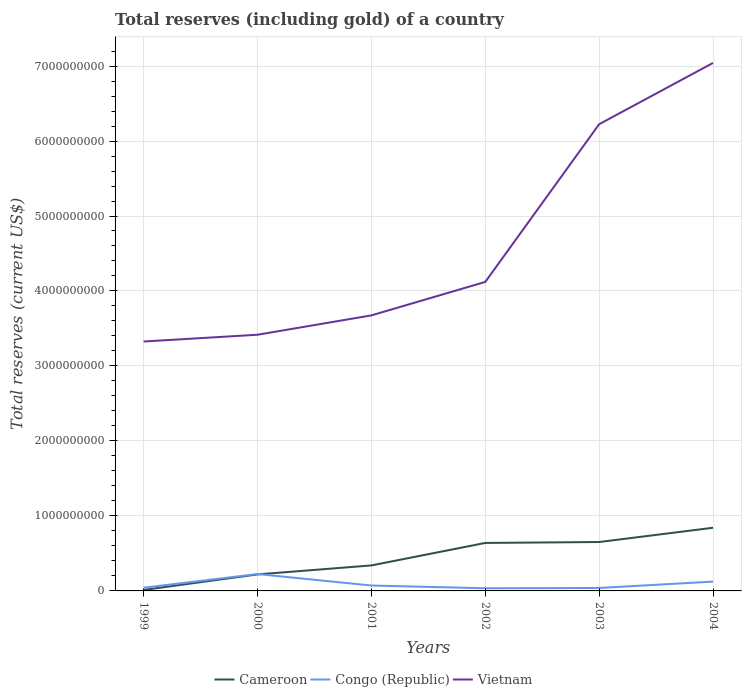Across all years, what is the maximum total reserves (including gold) in Congo (Republic)?
Your answer should be very brief. 3.54e+07. In which year was the total reserves (including gold) in Vietnam maximum?
Make the answer very short. 1999. What is the total total reserves (including gold) in Congo (Republic) in the graph?
Your response must be concise. 3.65e+07. What is the difference between the highest and the second highest total reserves (including gold) in Congo (Republic)?
Offer a terse response. 1.90e+08. What is the difference between the highest and the lowest total reserves (including gold) in Cameroon?
Offer a terse response. 3. Is the total reserves (including gold) in Vietnam strictly greater than the total reserves (including gold) in Cameroon over the years?
Offer a very short reply. No. How many years are there in the graph?
Your answer should be very brief. 6. Does the graph contain any zero values?
Offer a terse response. No. Does the graph contain grids?
Provide a short and direct response. Yes. Where does the legend appear in the graph?
Give a very brief answer. Bottom center. How many legend labels are there?
Make the answer very short. 3. What is the title of the graph?
Ensure brevity in your answer.  Total reserves (including gold) of a country. What is the label or title of the Y-axis?
Your answer should be compact. Total reserves (current US$). What is the Total reserves (current US$) in Cameroon in 1999?
Give a very brief answer. 1.31e+07. What is the Total reserves (current US$) of Congo (Republic) in 1999?
Your response must be concise. 4.26e+07. What is the Total reserves (current US$) in Vietnam in 1999?
Ensure brevity in your answer.  3.33e+09. What is the Total reserves (current US$) of Cameroon in 2000?
Give a very brief answer. 2.20e+08. What is the Total reserves (current US$) in Congo (Republic) in 2000?
Your answer should be compact. 2.25e+08. What is the Total reserves (current US$) in Vietnam in 2000?
Provide a succinct answer. 3.42e+09. What is the Total reserves (current US$) in Cameroon in 2001?
Your answer should be very brief. 3.40e+08. What is the Total reserves (current US$) in Congo (Republic) in 2001?
Offer a terse response. 7.20e+07. What is the Total reserves (current US$) in Vietnam in 2001?
Offer a very short reply. 3.67e+09. What is the Total reserves (current US$) in Cameroon in 2002?
Keep it short and to the point. 6.40e+08. What is the Total reserves (current US$) in Congo (Republic) in 2002?
Offer a terse response. 3.54e+07. What is the Total reserves (current US$) of Vietnam in 2002?
Ensure brevity in your answer.  4.12e+09. What is the Total reserves (current US$) of Cameroon in 2003?
Offer a terse response. 6.52e+08. What is the Total reserves (current US$) of Congo (Republic) in 2003?
Provide a succinct answer. 3.94e+07. What is the Total reserves (current US$) of Vietnam in 2003?
Your answer should be very brief. 6.22e+09. What is the Total reserves (current US$) in Cameroon in 2004?
Provide a succinct answer. 8.42e+08. What is the Total reserves (current US$) in Congo (Republic) in 2004?
Provide a succinct answer. 1.24e+08. What is the Total reserves (current US$) in Vietnam in 2004?
Ensure brevity in your answer.  7.04e+09. Across all years, what is the maximum Total reserves (current US$) in Cameroon?
Provide a short and direct response. 8.42e+08. Across all years, what is the maximum Total reserves (current US$) of Congo (Republic)?
Provide a short and direct response. 2.25e+08. Across all years, what is the maximum Total reserves (current US$) in Vietnam?
Make the answer very short. 7.04e+09. Across all years, what is the minimum Total reserves (current US$) of Cameroon?
Your answer should be very brief. 1.31e+07. Across all years, what is the minimum Total reserves (current US$) of Congo (Republic)?
Ensure brevity in your answer.  3.54e+07. Across all years, what is the minimum Total reserves (current US$) of Vietnam?
Keep it short and to the point. 3.33e+09. What is the total Total reserves (current US$) in Cameroon in the graph?
Offer a terse response. 2.71e+09. What is the total Total reserves (current US$) in Congo (Republic) in the graph?
Your answer should be compact. 5.39e+08. What is the total Total reserves (current US$) of Vietnam in the graph?
Your answer should be very brief. 2.78e+1. What is the difference between the Total reserves (current US$) of Cameroon in 1999 and that in 2000?
Provide a short and direct response. -2.07e+08. What is the difference between the Total reserves (current US$) in Congo (Republic) in 1999 and that in 2000?
Your answer should be very brief. -1.82e+08. What is the difference between the Total reserves (current US$) of Vietnam in 1999 and that in 2000?
Your response must be concise. -9.04e+07. What is the difference between the Total reserves (current US$) of Cameroon in 1999 and that in 2001?
Your response must be concise. -3.27e+08. What is the difference between the Total reserves (current US$) of Congo (Republic) in 1999 and that in 2001?
Offer a very short reply. -2.94e+07. What is the difference between the Total reserves (current US$) in Vietnam in 1999 and that in 2001?
Provide a succinct answer. -3.48e+08. What is the difference between the Total reserves (current US$) of Cameroon in 1999 and that in 2002?
Give a very brief answer. -6.27e+08. What is the difference between the Total reserves (current US$) in Congo (Republic) in 1999 and that in 2002?
Offer a very short reply. 7.14e+06. What is the difference between the Total reserves (current US$) of Vietnam in 1999 and that in 2002?
Make the answer very short. -7.95e+08. What is the difference between the Total reserves (current US$) in Cameroon in 1999 and that in 2003?
Offer a terse response. -6.39e+08. What is the difference between the Total reserves (current US$) of Congo (Republic) in 1999 and that in 2003?
Offer a very short reply. 3.14e+06. What is the difference between the Total reserves (current US$) in Vietnam in 1999 and that in 2003?
Your response must be concise. -2.90e+09. What is the difference between the Total reserves (current US$) in Cameroon in 1999 and that in 2004?
Give a very brief answer. -8.29e+08. What is the difference between the Total reserves (current US$) in Congo (Republic) in 1999 and that in 2004?
Keep it short and to the point. -8.19e+07. What is the difference between the Total reserves (current US$) in Vietnam in 1999 and that in 2004?
Provide a succinct answer. -3.72e+09. What is the difference between the Total reserves (current US$) of Cameroon in 2000 and that in 2001?
Your answer should be compact. -1.20e+08. What is the difference between the Total reserves (current US$) of Congo (Republic) in 2000 and that in 2001?
Provide a short and direct response. 1.53e+08. What is the difference between the Total reserves (current US$) in Vietnam in 2000 and that in 2001?
Your response must be concise. -2.58e+08. What is the difference between the Total reserves (current US$) in Cameroon in 2000 and that in 2002?
Your response must be concise. -4.20e+08. What is the difference between the Total reserves (current US$) in Congo (Republic) in 2000 and that in 2002?
Keep it short and to the point. 1.90e+08. What is the difference between the Total reserves (current US$) in Vietnam in 2000 and that in 2002?
Offer a terse response. -7.05e+08. What is the difference between the Total reserves (current US$) in Cameroon in 2000 and that in 2003?
Give a very brief answer. -4.32e+08. What is the difference between the Total reserves (current US$) of Congo (Republic) in 2000 and that in 2003?
Provide a succinct answer. 1.86e+08. What is the difference between the Total reserves (current US$) in Vietnam in 2000 and that in 2003?
Your response must be concise. -2.81e+09. What is the difference between the Total reserves (current US$) in Cameroon in 2000 and that in 2004?
Ensure brevity in your answer.  -6.22e+08. What is the difference between the Total reserves (current US$) of Congo (Republic) in 2000 and that in 2004?
Provide a short and direct response. 1.01e+08. What is the difference between the Total reserves (current US$) in Vietnam in 2000 and that in 2004?
Offer a very short reply. -3.62e+09. What is the difference between the Total reserves (current US$) of Cameroon in 2001 and that in 2002?
Offer a terse response. -3.00e+08. What is the difference between the Total reserves (current US$) of Congo (Republic) in 2001 and that in 2002?
Make the answer very short. 3.65e+07. What is the difference between the Total reserves (current US$) in Vietnam in 2001 and that in 2002?
Your answer should be compact. -4.46e+08. What is the difference between the Total reserves (current US$) in Cameroon in 2001 and that in 2003?
Provide a succinct answer. -3.12e+08. What is the difference between the Total reserves (current US$) of Congo (Republic) in 2001 and that in 2003?
Provide a short and direct response. 3.25e+07. What is the difference between the Total reserves (current US$) in Vietnam in 2001 and that in 2003?
Your answer should be compact. -2.55e+09. What is the difference between the Total reserves (current US$) of Cameroon in 2001 and that in 2004?
Your answer should be compact. -5.02e+08. What is the difference between the Total reserves (current US$) of Congo (Republic) in 2001 and that in 2004?
Your answer should be compact. -5.25e+07. What is the difference between the Total reserves (current US$) of Vietnam in 2001 and that in 2004?
Offer a terse response. -3.37e+09. What is the difference between the Total reserves (current US$) in Cameroon in 2002 and that in 2003?
Your answer should be compact. -1.22e+07. What is the difference between the Total reserves (current US$) of Congo (Republic) in 2002 and that in 2003?
Ensure brevity in your answer.  -3.99e+06. What is the difference between the Total reserves (current US$) of Vietnam in 2002 and that in 2003?
Ensure brevity in your answer.  -2.10e+09. What is the difference between the Total reserves (current US$) in Cameroon in 2002 and that in 2004?
Ensure brevity in your answer.  -2.02e+08. What is the difference between the Total reserves (current US$) of Congo (Republic) in 2002 and that in 2004?
Your answer should be very brief. -8.90e+07. What is the difference between the Total reserves (current US$) of Vietnam in 2002 and that in 2004?
Your response must be concise. -2.92e+09. What is the difference between the Total reserves (current US$) in Cameroon in 2003 and that in 2004?
Keep it short and to the point. -1.90e+08. What is the difference between the Total reserves (current US$) in Congo (Republic) in 2003 and that in 2004?
Your answer should be very brief. -8.50e+07. What is the difference between the Total reserves (current US$) in Vietnam in 2003 and that in 2004?
Provide a succinct answer. -8.17e+08. What is the difference between the Total reserves (current US$) of Cameroon in 1999 and the Total reserves (current US$) of Congo (Republic) in 2000?
Ensure brevity in your answer.  -2.12e+08. What is the difference between the Total reserves (current US$) in Cameroon in 1999 and the Total reserves (current US$) in Vietnam in 2000?
Offer a terse response. -3.40e+09. What is the difference between the Total reserves (current US$) in Congo (Republic) in 1999 and the Total reserves (current US$) in Vietnam in 2000?
Offer a very short reply. -3.37e+09. What is the difference between the Total reserves (current US$) of Cameroon in 1999 and the Total reserves (current US$) of Congo (Republic) in 2001?
Offer a terse response. -5.89e+07. What is the difference between the Total reserves (current US$) in Cameroon in 1999 and the Total reserves (current US$) in Vietnam in 2001?
Your response must be concise. -3.66e+09. What is the difference between the Total reserves (current US$) in Congo (Republic) in 1999 and the Total reserves (current US$) in Vietnam in 2001?
Your response must be concise. -3.63e+09. What is the difference between the Total reserves (current US$) in Cameroon in 1999 and the Total reserves (current US$) in Congo (Republic) in 2002?
Ensure brevity in your answer.  -2.23e+07. What is the difference between the Total reserves (current US$) in Cameroon in 1999 and the Total reserves (current US$) in Vietnam in 2002?
Keep it short and to the point. -4.11e+09. What is the difference between the Total reserves (current US$) of Congo (Republic) in 1999 and the Total reserves (current US$) of Vietnam in 2002?
Your answer should be compact. -4.08e+09. What is the difference between the Total reserves (current US$) of Cameroon in 1999 and the Total reserves (current US$) of Congo (Republic) in 2003?
Your answer should be very brief. -2.63e+07. What is the difference between the Total reserves (current US$) in Cameroon in 1999 and the Total reserves (current US$) in Vietnam in 2003?
Offer a terse response. -6.21e+09. What is the difference between the Total reserves (current US$) in Congo (Republic) in 1999 and the Total reserves (current US$) in Vietnam in 2003?
Provide a short and direct response. -6.18e+09. What is the difference between the Total reserves (current US$) in Cameroon in 1999 and the Total reserves (current US$) in Congo (Republic) in 2004?
Your answer should be compact. -1.11e+08. What is the difference between the Total reserves (current US$) in Cameroon in 1999 and the Total reserves (current US$) in Vietnam in 2004?
Keep it short and to the point. -7.03e+09. What is the difference between the Total reserves (current US$) in Congo (Republic) in 1999 and the Total reserves (current US$) in Vietnam in 2004?
Offer a very short reply. -7.00e+09. What is the difference between the Total reserves (current US$) in Cameroon in 2000 and the Total reserves (current US$) in Congo (Republic) in 2001?
Your answer should be compact. 1.48e+08. What is the difference between the Total reserves (current US$) of Cameroon in 2000 and the Total reserves (current US$) of Vietnam in 2001?
Your answer should be compact. -3.45e+09. What is the difference between the Total reserves (current US$) in Congo (Republic) in 2000 and the Total reserves (current US$) in Vietnam in 2001?
Keep it short and to the point. -3.45e+09. What is the difference between the Total reserves (current US$) in Cameroon in 2000 and the Total reserves (current US$) in Congo (Republic) in 2002?
Your answer should be compact. 1.85e+08. What is the difference between the Total reserves (current US$) of Cameroon in 2000 and the Total reserves (current US$) of Vietnam in 2002?
Your answer should be very brief. -3.90e+09. What is the difference between the Total reserves (current US$) of Congo (Republic) in 2000 and the Total reserves (current US$) of Vietnam in 2002?
Give a very brief answer. -3.90e+09. What is the difference between the Total reserves (current US$) in Cameroon in 2000 and the Total reserves (current US$) in Congo (Republic) in 2003?
Keep it short and to the point. 1.81e+08. What is the difference between the Total reserves (current US$) of Cameroon in 2000 and the Total reserves (current US$) of Vietnam in 2003?
Offer a very short reply. -6.00e+09. What is the difference between the Total reserves (current US$) in Congo (Republic) in 2000 and the Total reserves (current US$) in Vietnam in 2003?
Your answer should be compact. -6.00e+09. What is the difference between the Total reserves (current US$) of Cameroon in 2000 and the Total reserves (current US$) of Congo (Republic) in 2004?
Your response must be concise. 9.57e+07. What is the difference between the Total reserves (current US$) in Cameroon in 2000 and the Total reserves (current US$) in Vietnam in 2004?
Your answer should be compact. -6.82e+09. What is the difference between the Total reserves (current US$) of Congo (Republic) in 2000 and the Total reserves (current US$) of Vietnam in 2004?
Offer a very short reply. -6.82e+09. What is the difference between the Total reserves (current US$) of Cameroon in 2001 and the Total reserves (current US$) of Congo (Republic) in 2002?
Ensure brevity in your answer.  3.05e+08. What is the difference between the Total reserves (current US$) of Cameroon in 2001 and the Total reserves (current US$) of Vietnam in 2002?
Your response must be concise. -3.78e+09. What is the difference between the Total reserves (current US$) of Congo (Republic) in 2001 and the Total reserves (current US$) of Vietnam in 2002?
Your response must be concise. -4.05e+09. What is the difference between the Total reserves (current US$) in Cameroon in 2001 and the Total reserves (current US$) in Congo (Republic) in 2003?
Your answer should be very brief. 3.01e+08. What is the difference between the Total reserves (current US$) of Cameroon in 2001 and the Total reserves (current US$) of Vietnam in 2003?
Offer a very short reply. -5.88e+09. What is the difference between the Total reserves (current US$) of Congo (Republic) in 2001 and the Total reserves (current US$) of Vietnam in 2003?
Offer a terse response. -6.15e+09. What is the difference between the Total reserves (current US$) in Cameroon in 2001 and the Total reserves (current US$) in Congo (Republic) in 2004?
Your answer should be very brief. 2.16e+08. What is the difference between the Total reserves (current US$) in Cameroon in 2001 and the Total reserves (current US$) in Vietnam in 2004?
Ensure brevity in your answer.  -6.70e+09. What is the difference between the Total reserves (current US$) in Congo (Republic) in 2001 and the Total reserves (current US$) in Vietnam in 2004?
Offer a terse response. -6.97e+09. What is the difference between the Total reserves (current US$) in Cameroon in 2002 and the Total reserves (current US$) in Congo (Republic) in 2003?
Give a very brief answer. 6.00e+08. What is the difference between the Total reserves (current US$) in Cameroon in 2002 and the Total reserves (current US$) in Vietnam in 2003?
Your response must be concise. -5.58e+09. What is the difference between the Total reserves (current US$) in Congo (Republic) in 2002 and the Total reserves (current US$) in Vietnam in 2003?
Offer a very short reply. -6.19e+09. What is the difference between the Total reserves (current US$) in Cameroon in 2002 and the Total reserves (current US$) in Congo (Republic) in 2004?
Offer a terse response. 5.15e+08. What is the difference between the Total reserves (current US$) in Cameroon in 2002 and the Total reserves (current US$) in Vietnam in 2004?
Your answer should be compact. -6.40e+09. What is the difference between the Total reserves (current US$) of Congo (Republic) in 2002 and the Total reserves (current US$) of Vietnam in 2004?
Keep it short and to the point. -7.01e+09. What is the difference between the Total reserves (current US$) in Cameroon in 2003 and the Total reserves (current US$) in Congo (Republic) in 2004?
Make the answer very short. 5.28e+08. What is the difference between the Total reserves (current US$) of Cameroon in 2003 and the Total reserves (current US$) of Vietnam in 2004?
Your answer should be very brief. -6.39e+09. What is the difference between the Total reserves (current US$) in Congo (Republic) in 2003 and the Total reserves (current US$) in Vietnam in 2004?
Provide a succinct answer. -7.00e+09. What is the average Total reserves (current US$) in Cameroon per year?
Offer a very short reply. 4.51e+08. What is the average Total reserves (current US$) of Congo (Republic) per year?
Your answer should be very brief. 8.98e+07. What is the average Total reserves (current US$) of Vietnam per year?
Keep it short and to the point. 4.63e+09. In the year 1999, what is the difference between the Total reserves (current US$) in Cameroon and Total reserves (current US$) in Congo (Republic)?
Your answer should be compact. -2.95e+07. In the year 1999, what is the difference between the Total reserves (current US$) of Cameroon and Total reserves (current US$) of Vietnam?
Your response must be concise. -3.31e+09. In the year 1999, what is the difference between the Total reserves (current US$) in Congo (Republic) and Total reserves (current US$) in Vietnam?
Make the answer very short. -3.28e+09. In the year 2000, what is the difference between the Total reserves (current US$) of Cameroon and Total reserves (current US$) of Congo (Republic)?
Provide a succinct answer. -4.84e+06. In the year 2000, what is the difference between the Total reserves (current US$) in Cameroon and Total reserves (current US$) in Vietnam?
Offer a very short reply. -3.20e+09. In the year 2000, what is the difference between the Total reserves (current US$) in Congo (Republic) and Total reserves (current US$) in Vietnam?
Provide a succinct answer. -3.19e+09. In the year 2001, what is the difference between the Total reserves (current US$) of Cameroon and Total reserves (current US$) of Congo (Republic)?
Your answer should be very brief. 2.68e+08. In the year 2001, what is the difference between the Total reserves (current US$) in Cameroon and Total reserves (current US$) in Vietnam?
Provide a succinct answer. -3.33e+09. In the year 2001, what is the difference between the Total reserves (current US$) in Congo (Republic) and Total reserves (current US$) in Vietnam?
Your answer should be very brief. -3.60e+09. In the year 2002, what is the difference between the Total reserves (current US$) in Cameroon and Total reserves (current US$) in Congo (Republic)?
Make the answer very short. 6.04e+08. In the year 2002, what is the difference between the Total reserves (current US$) in Cameroon and Total reserves (current US$) in Vietnam?
Keep it short and to the point. -3.48e+09. In the year 2002, what is the difference between the Total reserves (current US$) of Congo (Republic) and Total reserves (current US$) of Vietnam?
Offer a terse response. -4.09e+09. In the year 2003, what is the difference between the Total reserves (current US$) of Cameroon and Total reserves (current US$) of Congo (Republic)?
Your answer should be compact. 6.13e+08. In the year 2003, what is the difference between the Total reserves (current US$) in Cameroon and Total reserves (current US$) in Vietnam?
Offer a very short reply. -5.57e+09. In the year 2003, what is the difference between the Total reserves (current US$) of Congo (Republic) and Total reserves (current US$) of Vietnam?
Make the answer very short. -6.18e+09. In the year 2004, what is the difference between the Total reserves (current US$) in Cameroon and Total reserves (current US$) in Congo (Republic)?
Ensure brevity in your answer.  7.18e+08. In the year 2004, what is the difference between the Total reserves (current US$) in Cameroon and Total reserves (current US$) in Vietnam?
Provide a short and direct response. -6.20e+09. In the year 2004, what is the difference between the Total reserves (current US$) of Congo (Republic) and Total reserves (current US$) of Vietnam?
Your answer should be compact. -6.92e+09. What is the ratio of the Total reserves (current US$) in Cameroon in 1999 to that in 2000?
Give a very brief answer. 0.06. What is the ratio of the Total reserves (current US$) in Congo (Republic) in 1999 to that in 2000?
Offer a terse response. 0.19. What is the ratio of the Total reserves (current US$) of Vietnam in 1999 to that in 2000?
Give a very brief answer. 0.97. What is the ratio of the Total reserves (current US$) of Cameroon in 1999 to that in 2001?
Offer a very short reply. 0.04. What is the ratio of the Total reserves (current US$) in Congo (Republic) in 1999 to that in 2001?
Your answer should be compact. 0.59. What is the ratio of the Total reserves (current US$) in Vietnam in 1999 to that in 2001?
Your response must be concise. 0.91. What is the ratio of the Total reserves (current US$) of Cameroon in 1999 to that in 2002?
Provide a short and direct response. 0.02. What is the ratio of the Total reserves (current US$) of Congo (Republic) in 1999 to that in 2002?
Give a very brief answer. 1.2. What is the ratio of the Total reserves (current US$) in Vietnam in 1999 to that in 2002?
Your response must be concise. 0.81. What is the ratio of the Total reserves (current US$) in Cameroon in 1999 to that in 2003?
Give a very brief answer. 0.02. What is the ratio of the Total reserves (current US$) in Congo (Republic) in 1999 to that in 2003?
Provide a short and direct response. 1.08. What is the ratio of the Total reserves (current US$) of Vietnam in 1999 to that in 2003?
Give a very brief answer. 0.53. What is the ratio of the Total reserves (current US$) of Cameroon in 1999 to that in 2004?
Your answer should be very brief. 0.02. What is the ratio of the Total reserves (current US$) in Congo (Republic) in 1999 to that in 2004?
Make the answer very short. 0.34. What is the ratio of the Total reserves (current US$) of Vietnam in 1999 to that in 2004?
Provide a short and direct response. 0.47. What is the ratio of the Total reserves (current US$) in Cameroon in 2000 to that in 2001?
Offer a terse response. 0.65. What is the ratio of the Total reserves (current US$) in Congo (Republic) in 2000 to that in 2001?
Provide a short and direct response. 3.13. What is the ratio of the Total reserves (current US$) in Vietnam in 2000 to that in 2001?
Your response must be concise. 0.93. What is the ratio of the Total reserves (current US$) of Cameroon in 2000 to that in 2002?
Provide a short and direct response. 0.34. What is the ratio of the Total reserves (current US$) of Congo (Republic) in 2000 to that in 2002?
Your answer should be very brief. 6.35. What is the ratio of the Total reserves (current US$) in Vietnam in 2000 to that in 2002?
Ensure brevity in your answer.  0.83. What is the ratio of the Total reserves (current US$) of Cameroon in 2000 to that in 2003?
Make the answer very short. 0.34. What is the ratio of the Total reserves (current US$) in Congo (Republic) in 2000 to that in 2003?
Make the answer very short. 5.71. What is the ratio of the Total reserves (current US$) of Vietnam in 2000 to that in 2003?
Keep it short and to the point. 0.55. What is the ratio of the Total reserves (current US$) in Cameroon in 2000 to that in 2004?
Your answer should be compact. 0.26. What is the ratio of the Total reserves (current US$) in Congo (Republic) in 2000 to that in 2004?
Ensure brevity in your answer.  1.81. What is the ratio of the Total reserves (current US$) of Vietnam in 2000 to that in 2004?
Give a very brief answer. 0.49. What is the ratio of the Total reserves (current US$) in Cameroon in 2001 to that in 2002?
Keep it short and to the point. 0.53. What is the ratio of the Total reserves (current US$) in Congo (Republic) in 2001 to that in 2002?
Provide a short and direct response. 2.03. What is the ratio of the Total reserves (current US$) of Vietnam in 2001 to that in 2002?
Make the answer very short. 0.89. What is the ratio of the Total reserves (current US$) in Cameroon in 2001 to that in 2003?
Offer a very short reply. 0.52. What is the ratio of the Total reserves (current US$) of Congo (Republic) in 2001 to that in 2003?
Provide a short and direct response. 1.83. What is the ratio of the Total reserves (current US$) of Vietnam in 2001 to that in 2003?
Provide a short and direct response. 0.59. What is the ratio of the Total reserves (current US$) of Cameroon in 2001 to that in 2004?
Make the answer very short. 0.4. What is the ratio of the Total reserves (current US$) in Congo (Republic) in 2001 to that in 2004?
Your answer should be very brief. 0.58. What is the ratio of the Total reserves (current US$) of Vietnam in 2001 to that in 2004?
Offer a very short reply. 0.52. What is the ratio of the Total reserves (current US$) in Cameroon in 2002 to that in 2003?
Your answer should be very brief. 0.98. What is the ratio of the Total reserves (current US$) of Congo (Republic) in 2002 to that in 2003?
Your answer should be compact. 0.9. What is the ratio of the Total reserves (current US$) in Vietnam in 2002 to that in 2003?
Provide a succinct answer. 0.66. What is the ratio of the Total reserves (current US$) of Cameroon in 2002 to that in 2004?
Offer a very short reply. 0.76. What is the ratio of the Total reserves (current US$) in Congo (Republic) in 2002 to that in 2004?
Ensure brevity in your answer.  0.28. What is the ratio of the Total reserves (current US$) in Vietnam in 2002 to that in 2004?
Provide a short and direct response. 0.59. What is the ratio of the Total reserves (current US$) of Cameroon in 2003 to that in 2004?
Provide a short and direct response. 0.77. What is the ratio of the Total reserves (current US$) in Congo (Republic) in 2003 to that in 2004?
Ensure brevity in your answer.  0.32. What is the ratio of the Total reserves (current US$) of Vietnam in 2003 to that in 2004?
Offer a terse response. 0.88. What is the difference between the highest and the second highest Total reserves (current US$) of Cameroon?
Your answer should be compact. 1.90e+08. What is the difference between the highest and the second highest Total reserves (current US$) in Congo (Republic)?
Give a very brief answer. 1.01e+08. What is the difference between the highest and the second highest Total reserves (current US$) of Vietnam?
Provide a succinct answer. 8.17e+08. What is the difference between the highest and the lowest Total reserves (current US$) of Cameroon?
Make the answer very short. 8.29e+08. What is the difference between the highest and the lowest Total reserves (current US$) in Congo (Republic)?
Your response must be concise. 1.90e+08. What is the difference between the highest and the lowest Total reserves (current US$) in Vietnam?
Provide a succinct answer. 3.72e+09. 